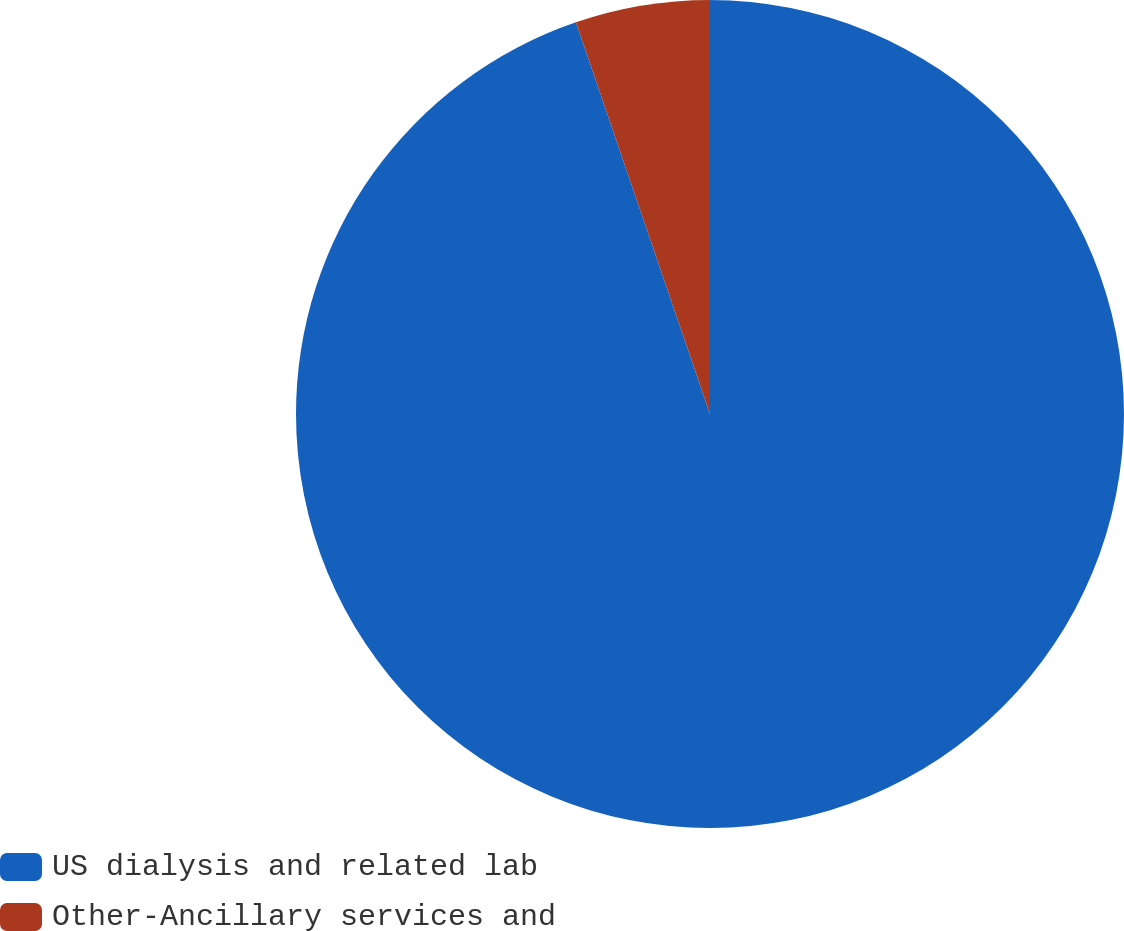Convert chart. <chart><loc_0><loc_0><loc_500><loc_500><pie_chart><fcel>US dialysis and related lab<fcel>Other-Ancillary services and<nl><fcel>94.75%<fcel>5.25%<nl></chart> 